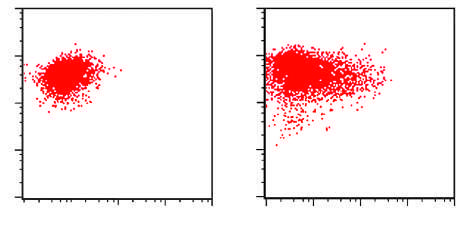does infective endocarditis result for the aml shown in the figure?
Answer the question using a single word or phrase. No 